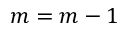<formula> <loc_0><loc_0><loc_500><loc_500>m = m - 1</formula> 